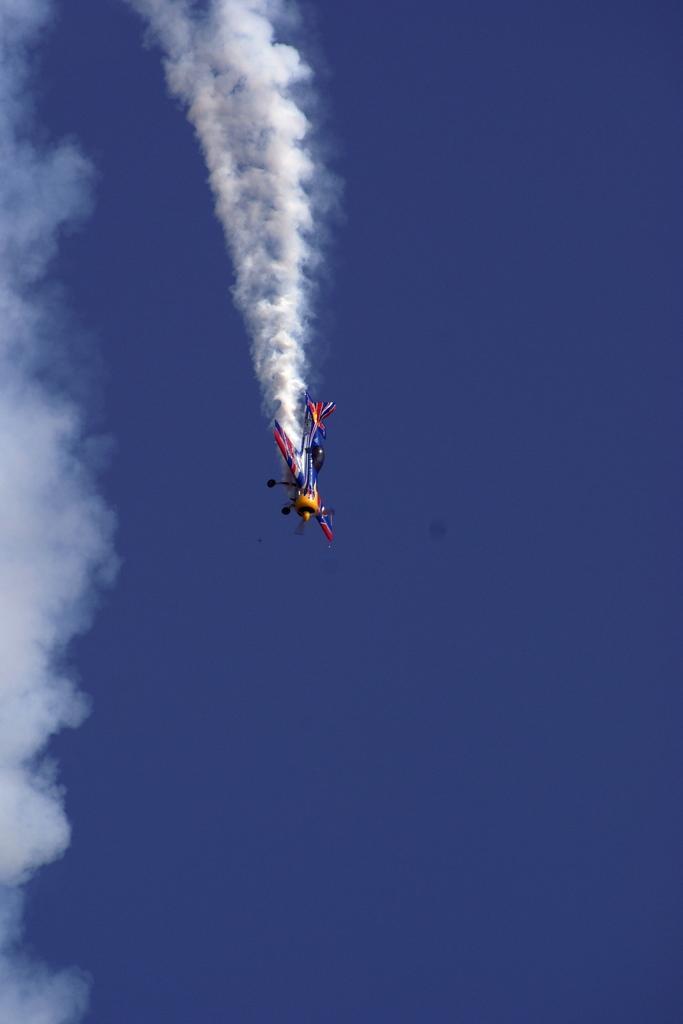Can you describe this image briefly? In this image I can see a aircraft which is yellow, blue and red in color is flying in the air. I can see the smoke behind it and in the background I can see the sky. 